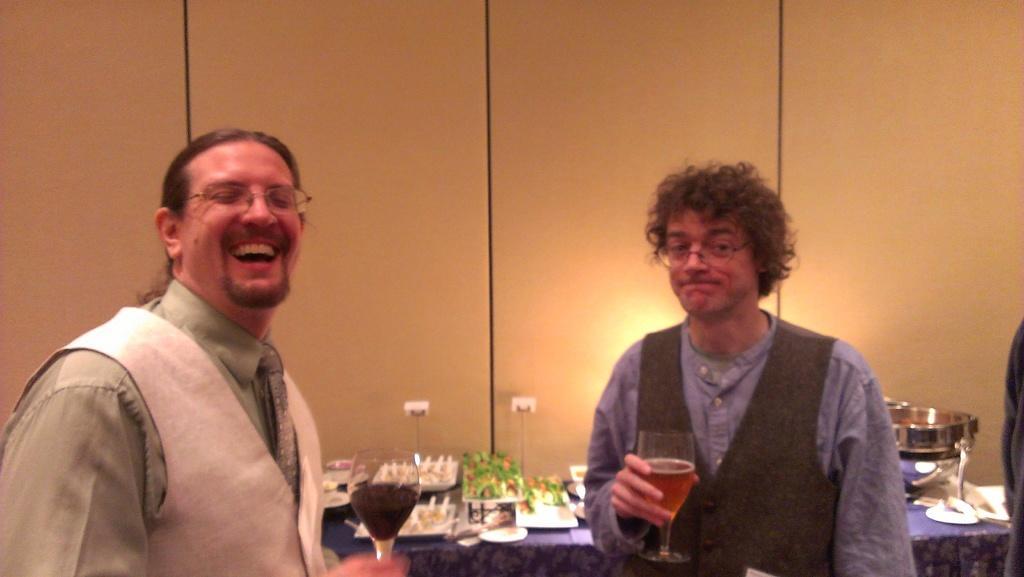How would you summarize this image in a sentence or two? In this image there are two people standing and holding glasses. In the background there is a table and we can see objects placed on the table and there is a wall. 